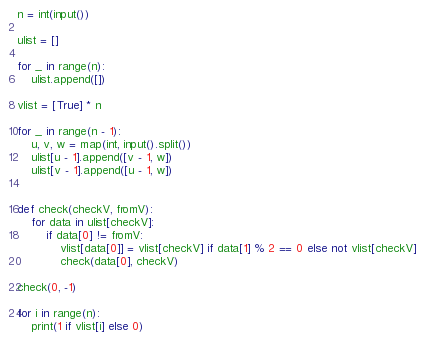Convert code to text. <code><loc_0><loc_0><loc_500><loc_500><_Python_>n = int(input())

ulist = []

for _ in range(n):
    ulist.append([])

vlist = [True] * n

for _ in range(n - 1):
    u, v, w = map(int, input().split())
    ulist[u - 1].append([v - 1, w])
    ulist[v - 1].append([u - 1, w])


def check(checkV, fromV):
    for data in ulist[checkV]:
        if data[0] != fromV:
            vlist[data[0]] = vlist[checkV] if data[1] % 2 == 0 else not vlist[checkV]
            check(data[0], checkV)

check(0, -1)

for i in range(n):
    print(1 if vlist[i] else 0)</code> 